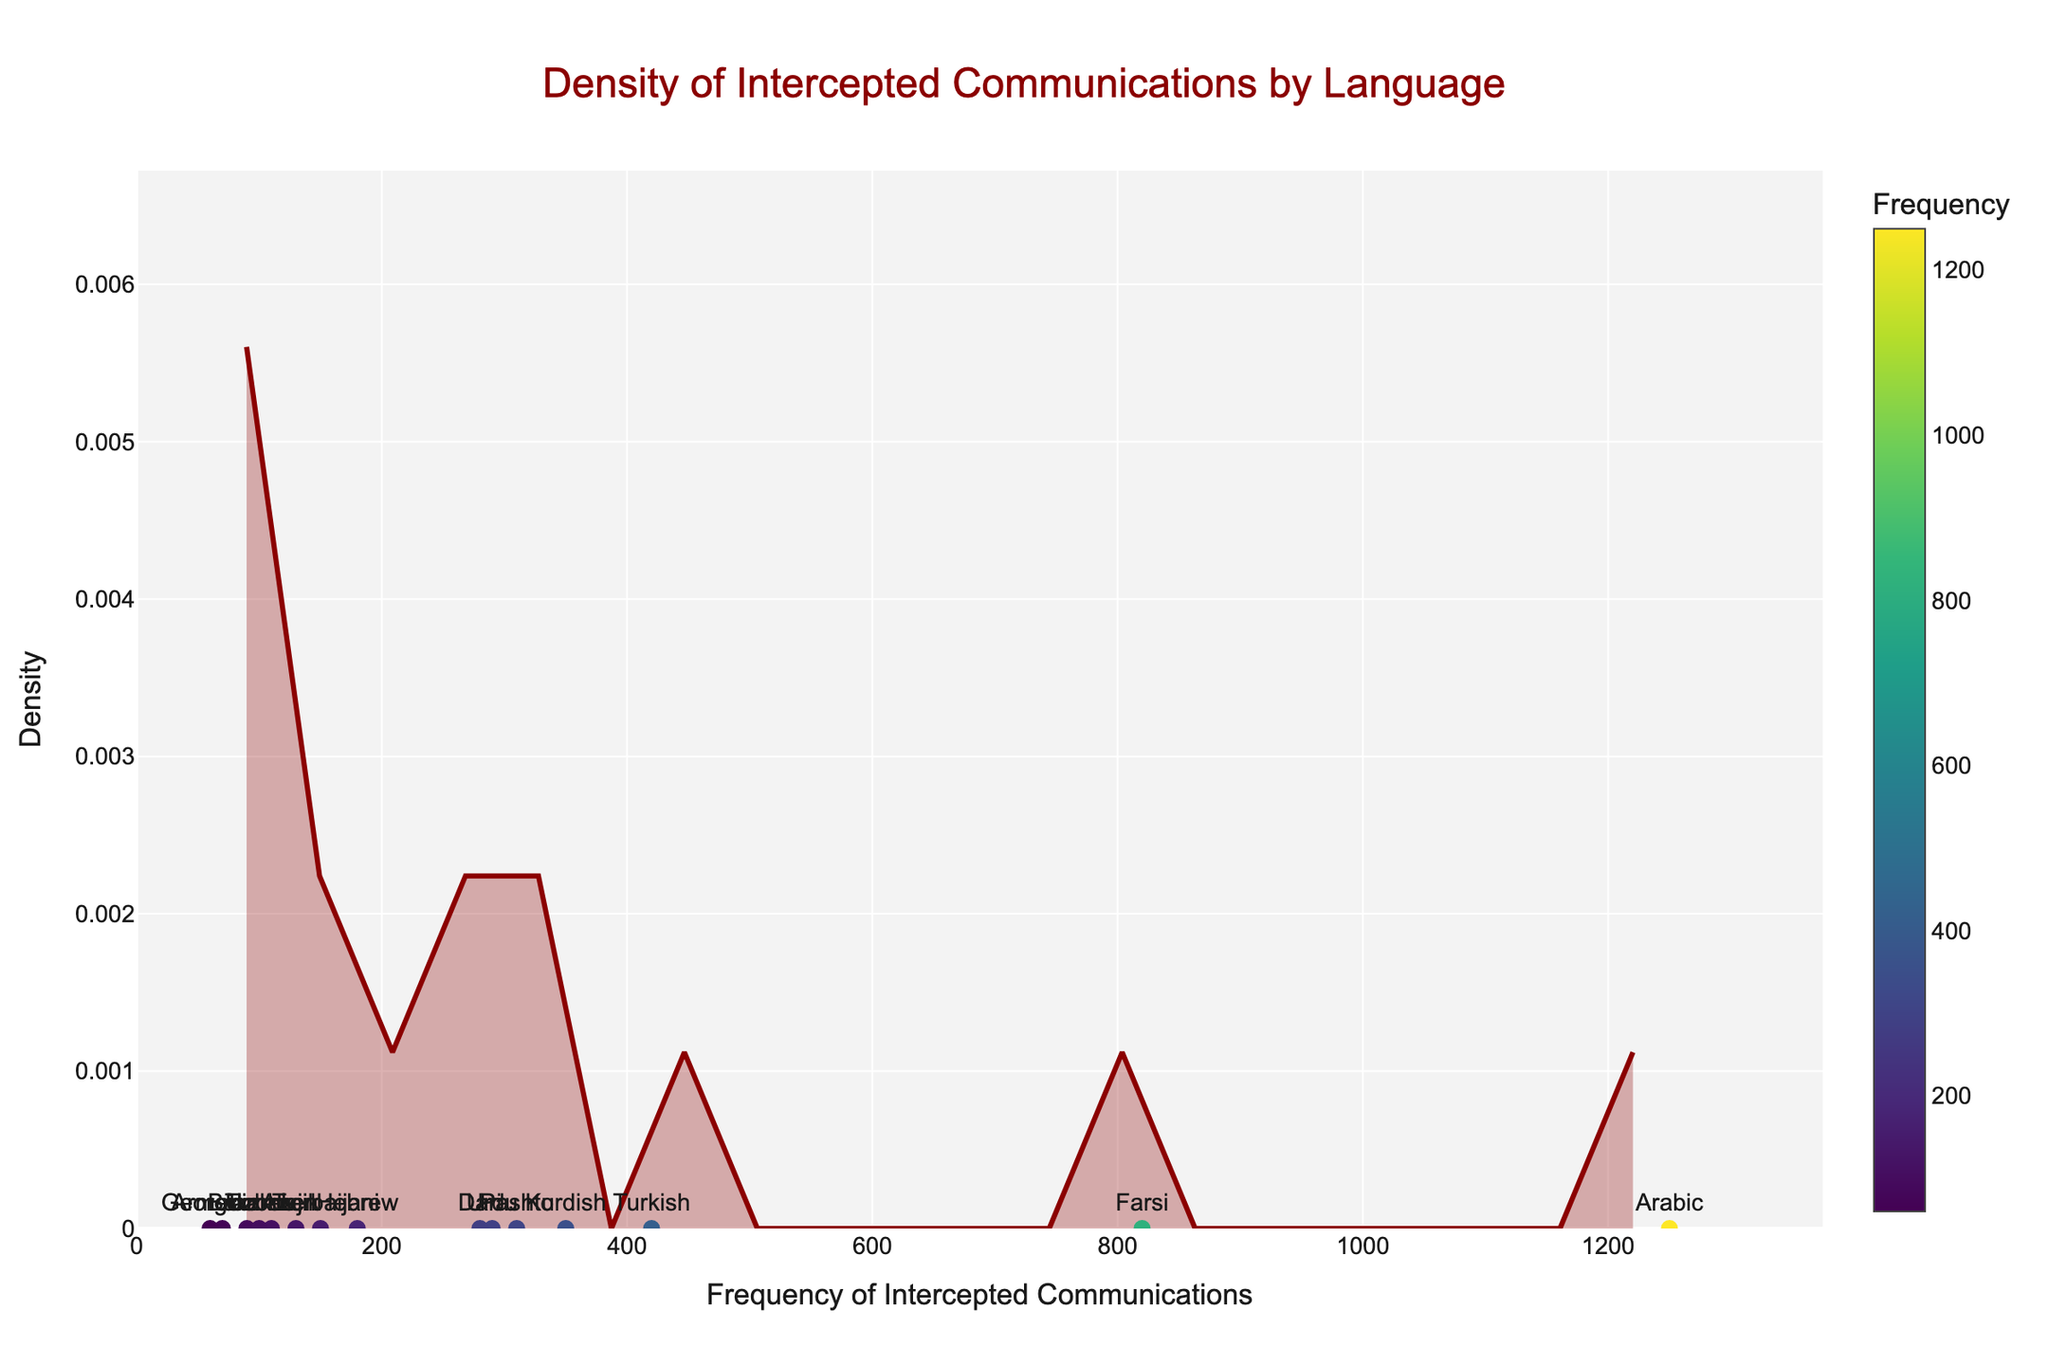What is the title of the figure? The title of the figure is located at the top and reads "Density of Intercepted Communications by Language".
Answer: Density of Intercepted Communications by Language Which language has the highest frequency of intercepted communications? To determine the language with the highest frequency, we look for the data point farthest to the right on the x-axis. The label associated with this data point denotes the language.
Answer: Arabic How many languages have a frequency of intercepted communications exceeding 300? By examining the scatter points on the x-axis and counting those with frequencies greater than 300, we can determine the number of languages that meet this criterion. The languages are Arabic, Farsi, Turkish, Kurdish, Pashto, and Urdu.
Answer: 6 Between Farsi and Urdu, which language has a higher frequency of intercepted communications? We compare the x-axis positions of the data points labeled "Farsi" and "Urdu". The point farther to the right indicates a higher frequency.
Answer: Farsi What is the approximate range of the density values in the plot? The range can be determined by looking at the y-axis, which represents density. The values start at 0 and extend to the highest point of the density curve.
Answer: 0 to around 0.004 Which language has the lowest frequency of intercepted communications? Identify the data point closest to the origin (0 on the x-axis) and note the language label associated with it.
Answer: Georgian What is the approximate frequency of intercepted communications for Turkish? Locate the scatter point labeled "Turkish" on the x-axis. The x-coordinate of this point represents the frequency for Turkish.
Answer: 420 How does the frequency of intercepted communications for Turkish compare with Kurdish? Locate the points labeled "Turkish" and "Kurdish" on the x-axis and compare their positions. Turkish is to the right of Kurdish, indicating a higher frequency.
Answer: Turkish is higher What is the density value at the frequency where Hebrew is plotted? Find the scatter point labeled "Hebrew" on the x-axis, and then look at the y-coordinate value of the underlying density curve at this point.
Answer: Between 0.003 and 0.004 